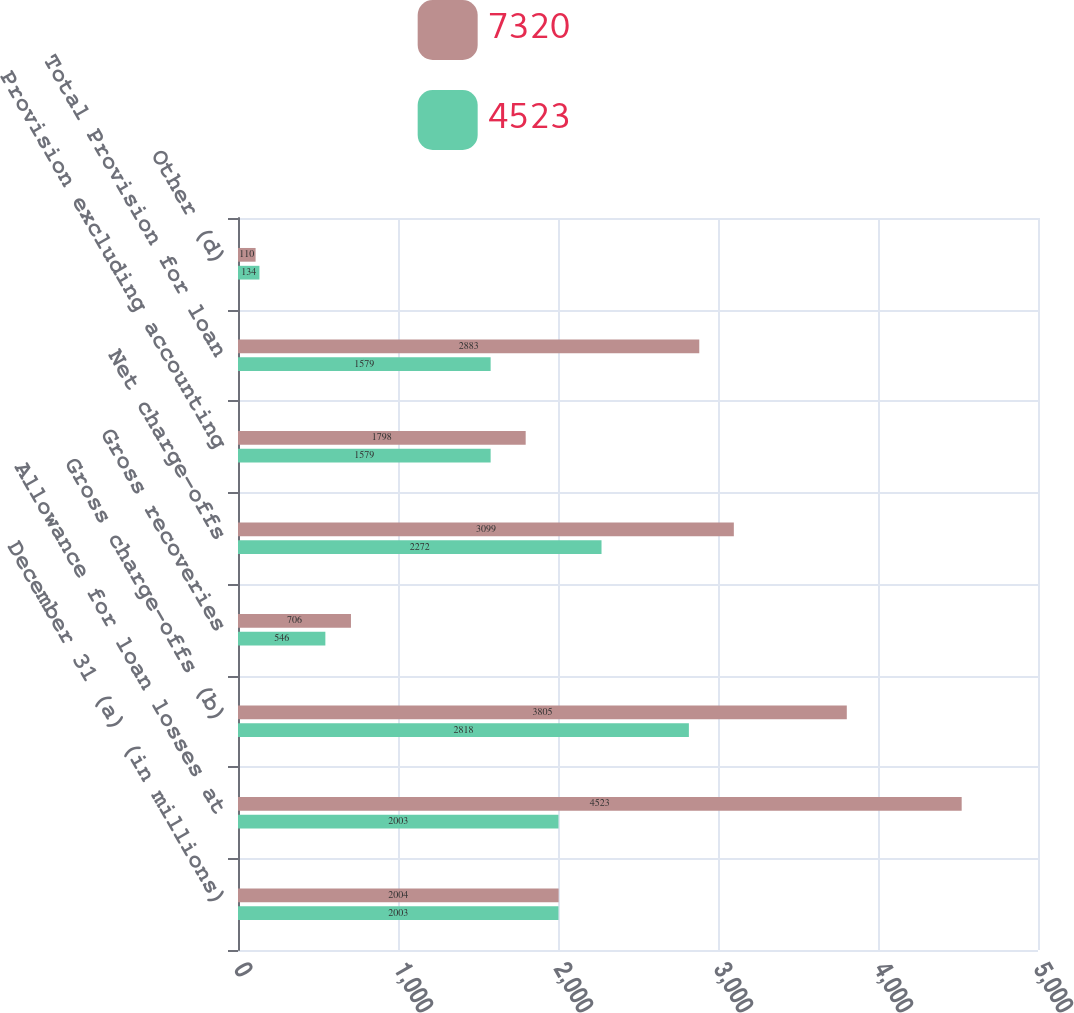Convert chart. <chart><loc_0><loc_0><loc_500><loc_500><stacked_bar_chart><ecel><fcel>December 31 (a) (in millions)<fcel>Allowance for loan losses at<fcel>Gross charge-offs (b)<fcel>Gross recoveries<fcel>Net charge-offs<fcel>Provision excluding accounting<fcel>Total Provision for loan<fcel>Other (d)<nl><fcel>7320<fcel>2004<fcel>4523<fcel>3805<fcel>706<fcel>3099<fcel>1798<fcel>2883<fcel>110<nl><fcel>4523<fcel>2003<fcel>2003<fcel>2818<fcel>546<fcel>2272<fcel>1579<fcel>1579<fcel>134<nl></chart> 